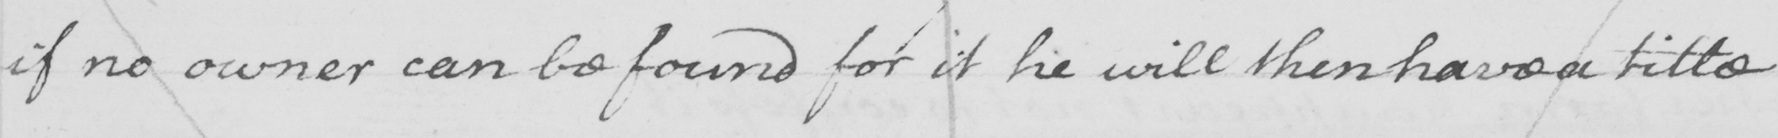Transcribe the text shown in this historical manuscript line. if no owner can be found for it he will then have a title . 